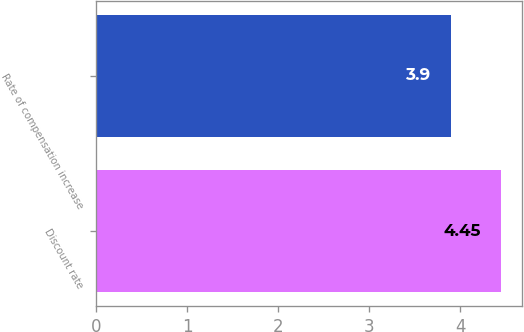Convert chart. <chart><loc_0><loc_0><loc_500><loc_500><bar_chart><fcel>Discount rate<fcel>Rate of compensation increase<nl><fcel>4.45<fcel>3.9<nl></chart> 